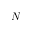<formula> <loc_0><loc_0><loc_500><loc_500>N</formula> 